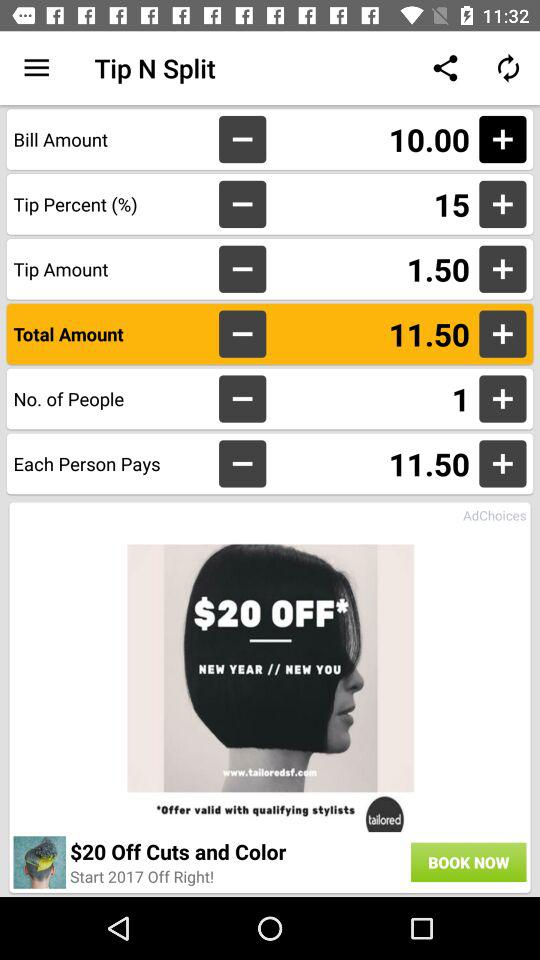What is the name of the application? The name of the application is "Tip N Split". 